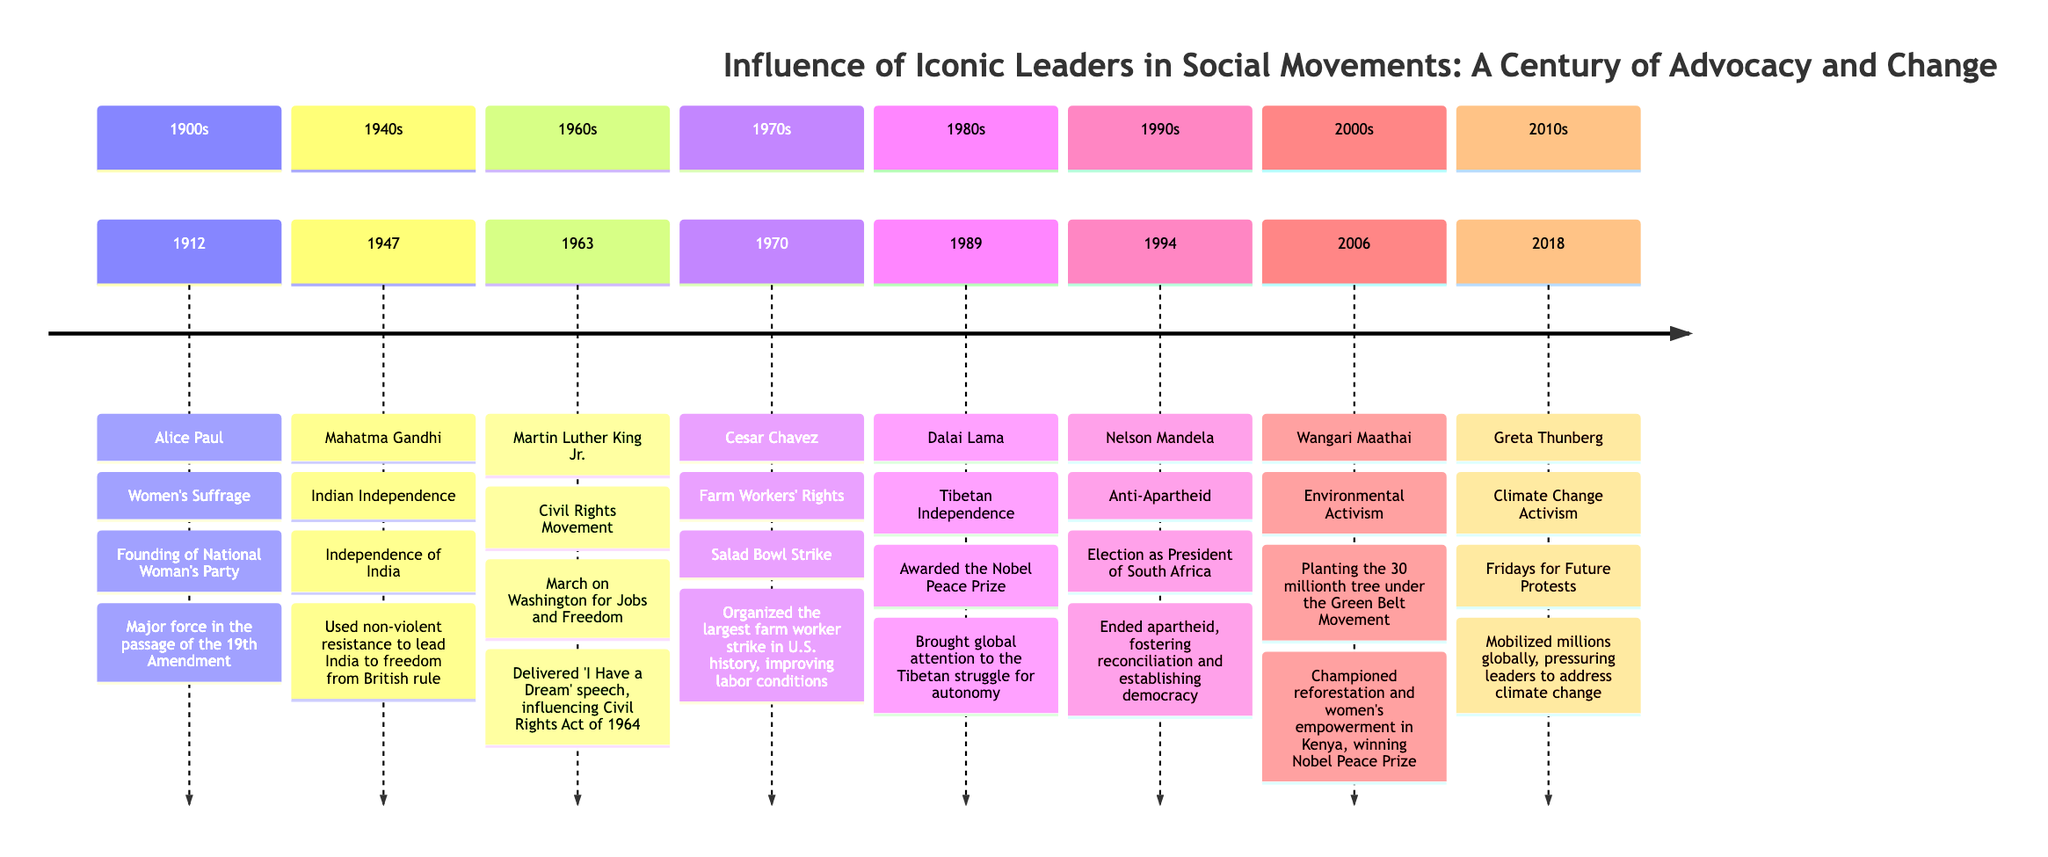What year did Alice Paul found the National Woman's Party? The timeline shows that Alice Paul founded the National Woman's Party in the year 1912.
Answer: 1912 Who organized the largest farm worker strike in U.S. history? The timeline indicates that Cesar Chavez organized the largest farm worker strike in U.S. history during the Salad Bowl Strike in 1970.
Answer: Cesar Chavez Which leader was awarded the Nobel Peace Prize in 1989? According to the timeline, the Dalai Lama was awarded the Nobel Peace Prize in 1989 for his efforts regarding Tibetan independence.
Answer: Dalai Lama How many key figures are listed in the timeline? By counting the individual leaders presented in the timeline, there are eight key figures listed, spanning from 1912 to 2018.
Answer: 8 What significant event did Martin Luther King Jr. lead in 1963? The timeline states that Martin Luther King Jr. led the March on Washington for Jobs and Freedom in 1963.
Answer: March on Washington for Jobs and Freedom Which movement was Wangari Maathai associated with? The timeline shows that Wangari Maathai was associated with the Environmental Activism movement.
Answer: Environmental Activism In what year did Nelson Mandela become President of South Africa? The timeline notes that Nelson Mandela was elected as President of South Africa in 1994.
Answer: 1994 What impact did Alice Paul's efforts have on the 19th Amendment? The timeline indicates that Alice Paul's work was a major force in the passage of the 19th Amendment, which granted women the right to vote.
Answer: Major force in the passage of the 19th Amendment During which decade did Greta Thunberg mobilize global protests? According to the timeline, Greta Thunberg mobilized global protests during 2010s, specifically through the Fridays for Future protests in 2018.
Answer: 2010s 